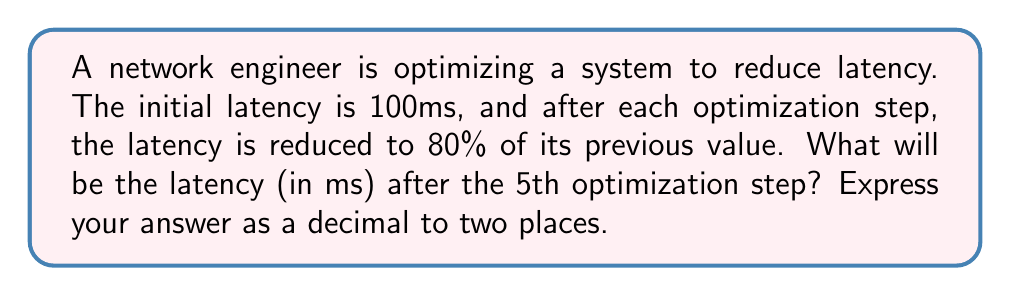Show me your answer to this math problem. Let's approach this step-by-step:

1) We're dealing with a geometric sequence where each term is 80% of the previous term.
   The common ratio is therefore $r = 0.8$.

2) The initial term (a₁) is 100ms.

3) We need to find the 6th term (a₆) because we're looking at the latency after 5 steps of optimization.

4) The formula for the nth term of a geometric sequence is:

   $$a_n = a_1 \cdot r^{n-1}$$

5) Plugging in our values:

   $$a_6 = 100 \cdot (0.8)^{5}$$

6) Let's calculate this:
   $$\begin{align}
   a_6 &= 100 \cdot (0.8)^{5} \\
   &= 100 \cdot 0.32768 \\
   &= 32.768
   \end{align}$$

7) Rounding to two decimal places: 32.77ms

This aligns with the developer's need to understand technical requirements, as it demonstrates how repeated optimizations affect system performance in a quantifiable way.
Answer: 32.77ms 